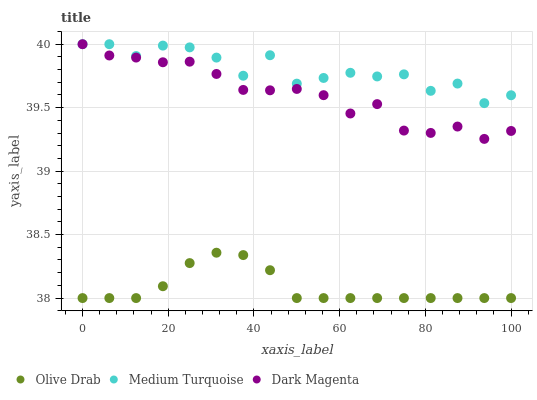Does Olive Drab have the minimum area under the curve?
Answer yes or no. Yes. Does Medium Turquoise have the maximum area under the curve?
Answer yes or no. Yes. Does Dark Magenta have the minimum area under the curve?
Answer yes or no. No. Does Dark Magenta have the maximum area under the curve?
Answer yes or no. No. Is Olive Drab the smoothest?
Answer yes or no. Yes. Is Medium Turquoise the roughest?
Answer yes or no. Yes. Is Dark Magenta the smoothest?
Answer yes or no. No. Is Dark Magenta the roughest?
Answer yes or no. No. Does Olive Drab have the lowest value?
Answer yes or no. Yes. Does Dark Magenta have the lowest value?
Answer yes or no. No. Does Dark Magenta have the highest value?
Answer yes or no. Yes. Does Olive Drab have the highest value?
Answer yes or no. No. Is Olive Drab less than Dark Magenta?
Answer yes or no. Yes. Is Medium Turquoise greater than Olive Drab?
Answer yes or no. Yes. Does Medium Turquoise intersect Dark Magenta?
Answer yes or no. Yes. Is Medium Turquoise less than Dark Magenta?
Answer yes or no. No. Is Medium Turquoise greater than Dark Magenta?
Answer yes or no. No. Does Olive Drab intersect Dark Magenta?
Answer yes or no. No. 